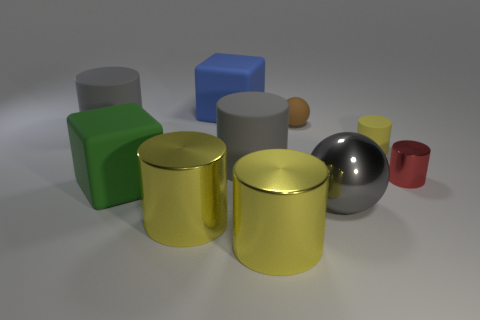What number of other things are there of the same color as the small metal object?
Keep it short and to the point. 0. Does the small matte cylinder have the same color as the tiny shiny cylinder?
Your response must be concise. No. How big is the ball in front of the large rubber object to the left of the big green rubber block?
Provide a short and direct response. Large. Is the material of the cube left of the large blue rubber block the same as the large yellow thing that is on the left side of the blue matte block?
Ensure brevity in your answer.  No. There is a matte block in front of the blue block; is it the same color as the metal sphere?
Offer a terse response. No. How many big cylinders are behind the yellow rubber thing?
Provide a succinct answer. 1. Does the gray sphere have the same material as the big gray cylinder that is in front of the small matte cylinder?
Your answer should be compact. No. The green object that is the same material as the blue thing is what size?
Keep it short and to the point. Large. Is the number of big blue things on the right side of the brown ball greater than the number of brown balls that are right of the tiny yellow cylinder?
Provide a succinct answer. No. Is there a big gray object that has the same shape as the small red metal object?
Offer a terse response. Yes. 